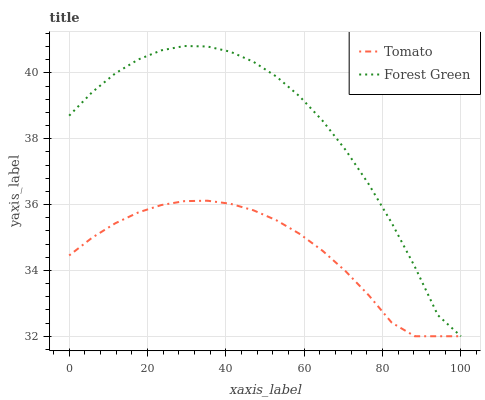Does Tomato have the minimum area under the curve?
Answer yes or no. Yes. Does Forest Green have the maximum area under the curve?
Answer yes or no. Yes. Does Forest Green have the minimum area under the curve?
Answer yes or no. No. Is Tomato the smoothest?
Answer yes or no. Yes. Is Forest Green the roughest?
Answer yes or no. Yes. Is Forest Green the smoothest?
Answer yes or no. No. Does Tomato have the lowest value?
Answer yes or no. Yes. Does Forest Green have the highest value?
Answer yes or no. Yes. Does Tomato intersect Forest Green?
Answer yes or no. Yes. Is Tomato less than Forest Green?
Answer yes or no. No. Is Tomato greater than Forest Green?
Answer yes or no. No. 